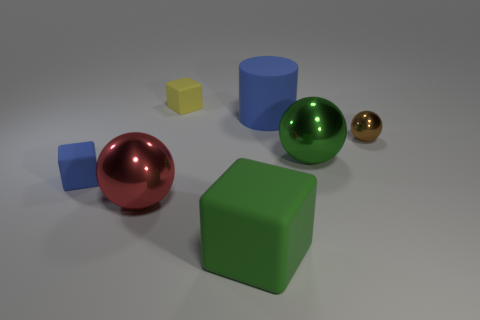Subtract all tiny blocks. How many blocks are left? 1 Add 3 small brown metallic things. How many objects exist? 10 Subtract all spheres. How many objects are left? 4 Subtract all blue spheres. Subtract all cyan blocks. How many spheres are left? 3 Subtract 0 brown cylinders. How many objects are left? 7 Subtract all green things. Subtract all brown balls. How many objects are left? 4 Add 4 matte blocks. How many matte blocks are left? 7 Add 1 large cyan spheres. How many large cyan spheres exist? 1 